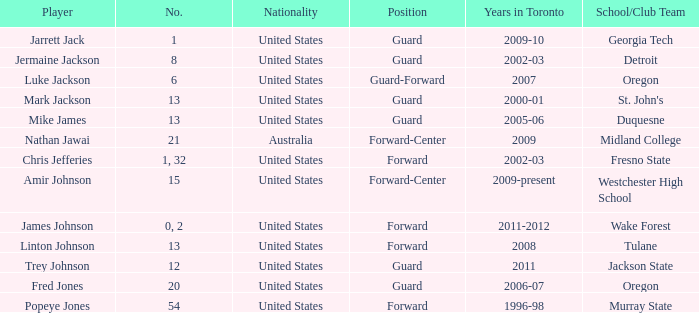Could you help me parse every detail presented in this table? {'header': ['Player', 'No.', 'Nationality', 'Position', 'Years in Toronto', 'School/Club Team'], 'rows': [['Jarrett Jack', '1', 'United States', 'Guard', '2009-10', 'Georgia Tech'], ['Jermaine Jackson', '8', 'United States', 'Guard', '2002-03', 'Detroit'], ['Luke Jackson', '6', 'United States', 'Guard-Forward', '2007', 'Oregon'], ['Mark Jackson', '13', 'United States', 'Guard', '2000-01', "St. John's"], ['Mike James', '13', 'United States', 'Guard', '2005-06', 'Duquesne'], ['Nathan Jawai', '21', 'Australia', 'Forward-Center', '2009', 'Midland College'], ['Chris Jefferies', '1, 32', 'United States', 'Forward', '2002-03', 'Fresno State'], ['Amir Johnson', '15', 'United States', 'Forward-Center', '2009-present', 'Westchester High School'], ['James Johnson', '0, 2', 'United States', 'Forward', '2011-2012', 'Wake Forest'], ['Linton Johnson', '13', 'United States', 'Forward', '2008', 'Tulane'], ['Trey Johnson', '12', 'United States', 'Guard', '2011', 'Jackson State'], ['Fred Jones', '20', 'United States', 'Guard', '2006-07', 'Oregon'], ['Popeye Jones', '54', 'United States', 'Forward', '1996-98', 'Murray State']]} What school/club team is Trey Johnson on? Jackson State. 